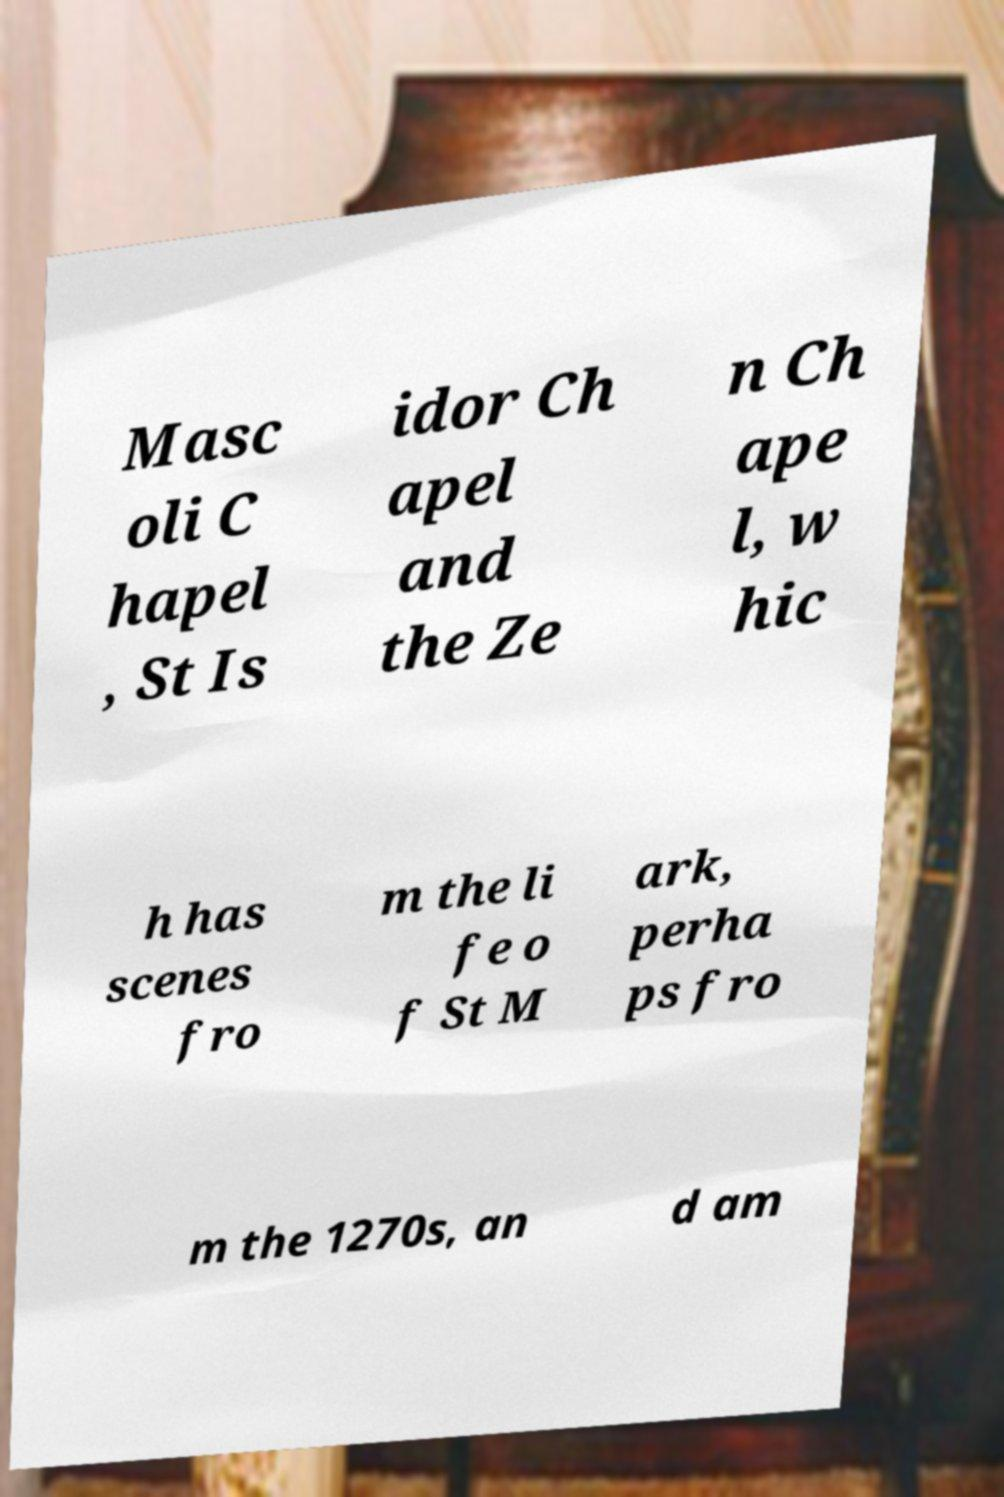Could you assist in decoding the text presented in this image and type it out clearly? Masc oli C hapel , St Is idor Ch apel and the Ze n Ch ape l, w hic h has scenes fro m the li fe o f St M ark, perha ps fro m the 1270s, an d am 